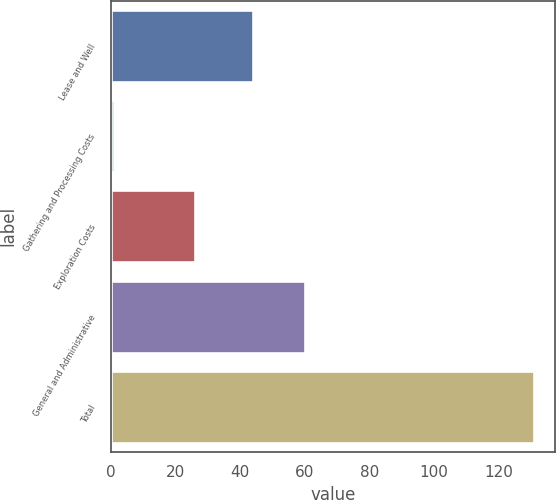Convert chart. <chart><loc_0><loc_0><loc_500><loc_500><bar_chart><fcel>Lease and Well<fcel>Gathering and Processing Costs<fcel>Exploration Costs<fcel>General and Administrative<fcel>Total<nl><fcel>44<fcel>1<fcel>26<fcel>60<fcel>131<nl></chart> 